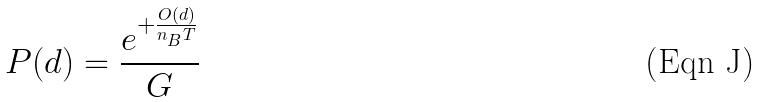Convert formula to latex. <formula><loc_0><loc_0><loc_500><loc_500>P ( d ) = \frac { e ^ { + \frac { O ( d ) } { n _ { B } T } } } { G }</formula> 